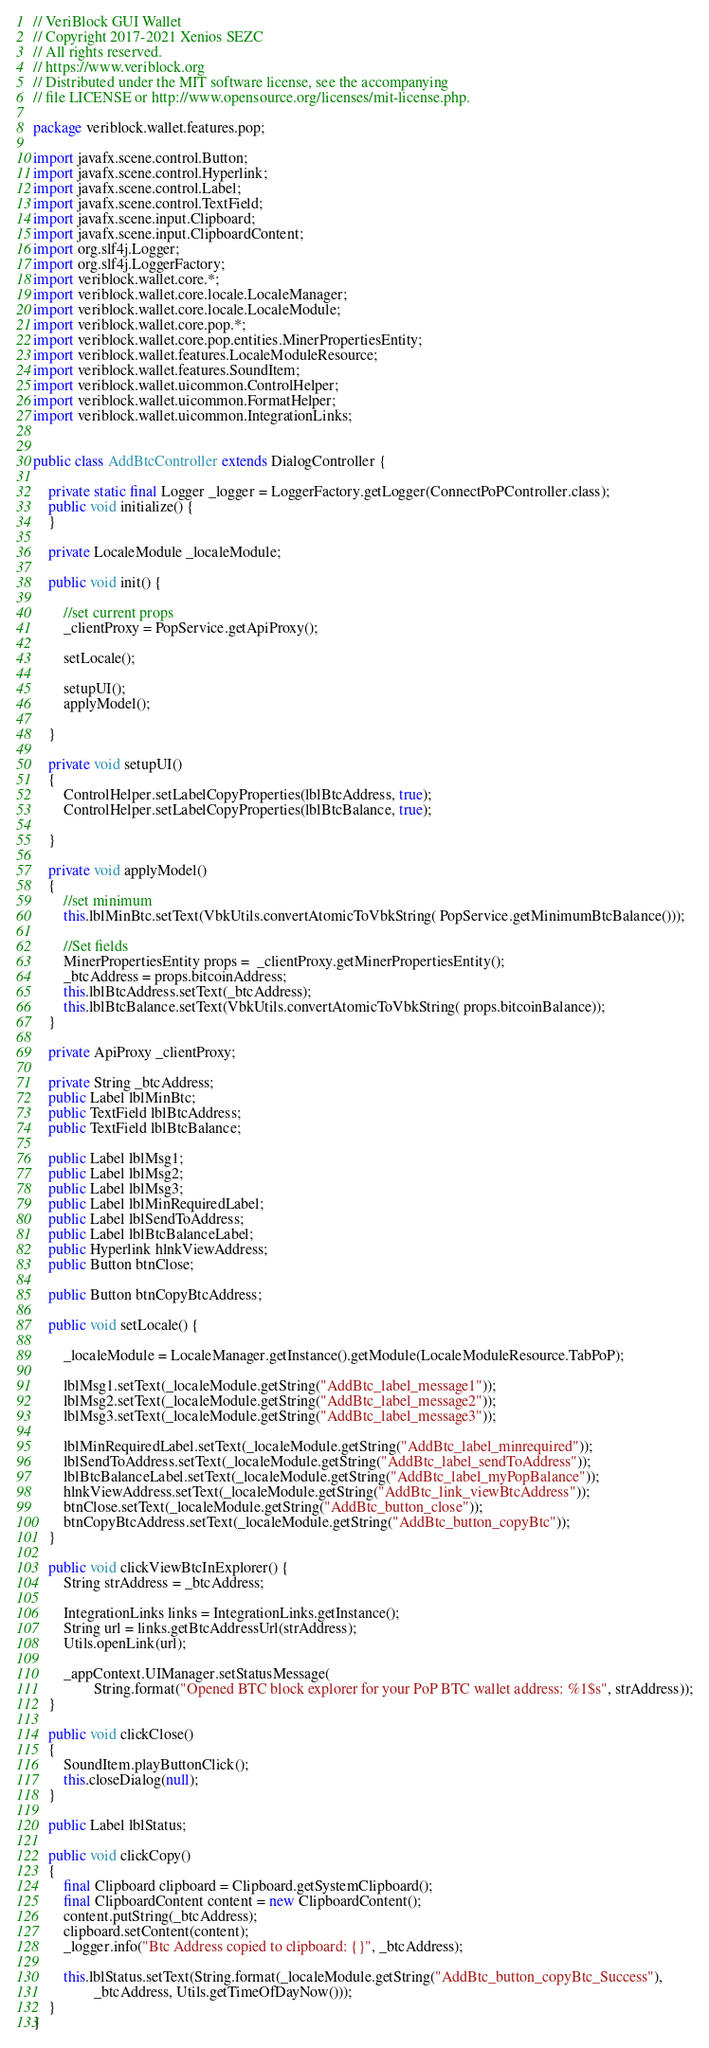Convert code to text. <code><loc_0><loc_0><loc_500><loc_500><_Java_>// VeriBlock GUI Wallet
// Copyright 2017-2021 Xenios SEZC
// All rights reserved.
// https://www.veriblock.org
// Distributed under the MIT software license, see the accompanying
// file LICENSE or http://www.opensource.org/licenses/mit-license.php.

package veriblock.wallet.features.pop;

import javafx.scene.control.Button;
import javafx.scene.control.Hyperlink;
import javafx.scene.control.Label;
import javafx.scene.control.TextField;
import javafx.scene.input.Clipboard;
import javafx.scene.input.ClipboardContent;
import org.slf4j.Logger;
import org.slf4j.LoggerFactory;
import veriblock.wallet.core.*;
import veriblock.wallet.core.locale.LocaleManager;
import veriblock.wallet.core.locale.LocaleModule;
import veriblock.wallet.core.pop.*;
import veriblock.wallet.core.pop.entities.MinerPropertiesEntity;
import veriblock.wallet.features.LocaleModuleResource;
import veriblock.wallet.features.SoundItem;
import veriblock.wallet.uicommon.ControlHelper;
import veriblock.wallet.uicommon.FormatHelper;
import veriblock.wallet.uicommon.IntegrationLinks;


public class AddBtcController extends DialogController {

    private static final Logger _logger = LoggerFactory.getLogger(ConnectPoPController.class);
    public void initialize() {
    }

    private LocaleModule _localeModule;

    public void init() {

        //set current props
        _clientProxy = PopService.getApiProxy();

        setLocale();

        setupUI();
        applyModel();

    }

    private void setupUI()
    {
        ControlHelper.setLabelCopyProperties(lblBtcAddress, true);
        ControlHelper.setLabelCopyProperties(lblBtcBalance, true);

    }

    private void applyModel()
    {
        //set minimum
        this.lblMinBtc.setText(VbkUtils.convertAtomicToVbkString( PopService.getMinimumBtcBalance()));

        //Set fields
        MinerPropertiesEntity props =  _clientProxy.getMinerPropertiesEntity();
        _btcAddress = props.bitcoinAddress;
        this.lblBtcAddress.setText(_btcAddress);
        this.lblBtcBalance.setText(VbkUtils.convertAtomicToVbkString( props.bitcoinBalance));
    }

    private ApiProxy _clientProxy;

    private String _btcAddress;
    public Label lblMinBtc;
    public TextField lblBtcAddress;
    public TextField lblBtcBalance;

    public Label lblMsg1;
    public Label lblMsg2;
    public Label lblMsg3;
    public Label lblMinRequiredLabel;
    public Label lblSendToAddress;
    public Label lblBtcBalanceLabel;
    public Hyperlink hlnkViewAddress;
    public Button btnClose;

    public Button btnCopyBtcAddress;

    public void setLocale() {

        _localeModule = LocaleManager.getInstance().getModule(LocaleModuleResource.TabPoP);

        lblMsg1.setText(_localeModule.getString("AddBtc_label_message1"));
        lblMsg2.setText(_localeModule.getString("AddBtc_label_message2"));
        lblMsg3.setText(_localeModule.getString("AddBtc_label_message3"));

        lblMinRequiredLabel.setText(_localeModule.getString("AddBtc_label_minrequired"));
        lblSendToAddress.setText(_localeModule.getString("AddBtc_label_sendToAddress"));
        lblBtcBalanceLabel.setText(_localeModule.getString("AddBtc_label_myPopBalance"));
        hlnkViewAddress.setText(_localeModule.getString("AddBtc_link_viewBtcAddress"));
        btnClose.setText(_localeModule.getString("AddBtc_button_close"));
        btnCopyBtcAddress.setText(_localeModule.getString("AddBtc_button_copyBtc"));
    }

    public void clickViewBtcInExplorer() {
        String strAddress = _btcAddress;

        IntegrationLinks links = IntegrationLinks.getInstance();
        String url = links.getBtcAddressUrl(strAddress);
        Utils.openLink(url);

        _appContext.UIManager.setStatusMessage(
                String.format("Opened BTC block explorer for your PoP BTC wallet address: %1$s", strAddress));
    }

    public void clickClose()
    {
        SoundItem.playButtonClick();
        this.closeDialog(null);
    }

    public Label lblStatus;

    public void clickCopy()
    {
        final Clipboard clipboard = Clipboard.getSystemClipboard();
        final ClipboardContent content = new ClipboardContent();
        content.putString(_btcAddress);
        clipboard.setContent(content);
        _logger.info("Btc Address copied to clipboard: {}", _btcAddress);

        this.lblStatus.setText(String.format(_localeModule.getString("AddBtc_button_copyBtc_Success"),
                _btcAddress, Utils.getTimeOfDayNow()));
    }
}
</code> 